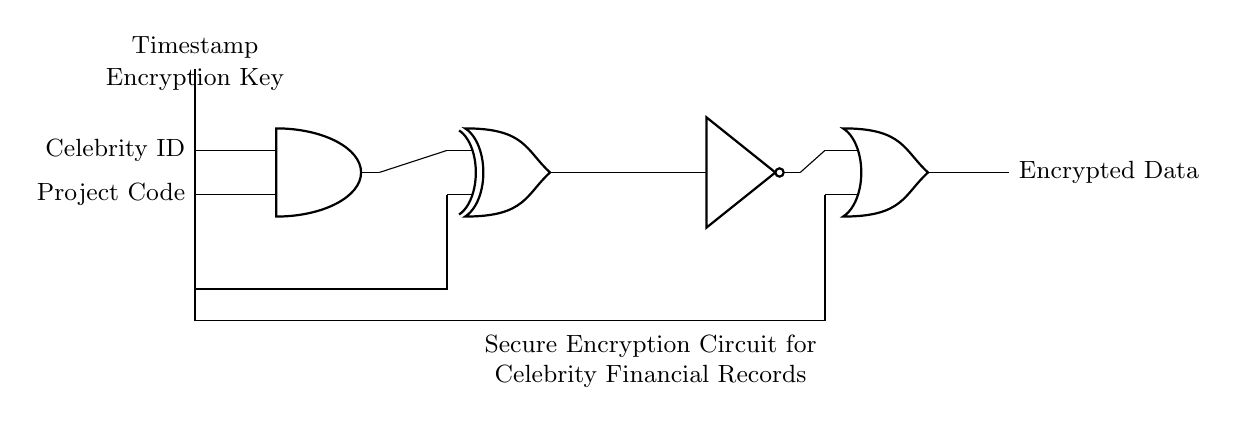What is the output of the circuit? The output of the circuit is referred to as the Encrypted Data, which is the final result after processing inputs through the logic gates.
Answer: Encrypted Data What type of logic gate is used to combine the Celebrity ID and Project Code? The circuit uses an AND gate to process the inputs from the Celebrity ID and Project Code, as indicated by the symbol and the connections.
Answer: AND gate How many inputs does the OR gate have? The OR gate has two inputs: one from the NOT gate and another from the Timestamp. This is shown by the two input lines leading to the OR gate.
Answer: Two What is used as the second input to the XOR gate? The second input to the XOR gate is the Encryption Key. It connects to the XOR gate, which is necessary for the encryption process.
Answer: Encryption Key What is the purpose of the NOT gate in this circuit? The NOT gate inverts the output from the XOR gate, thereby adding an additional security layer by changing the binary value it receives.
Answer: Inversion of XOR output What are the names of the inputs to the AND gate? The inputs to the AND gate are the Celebrity ID and Project Code, as labeled and connected to the AND gate in the circuit diagram.
Answer: Celebrity ID and Project Code What component retrieves the current time in this circuit? The component responsible for retrieving the current time is labeled as Timestamp, which connects to the OR gate for the final output.
Answer: Timestamp 